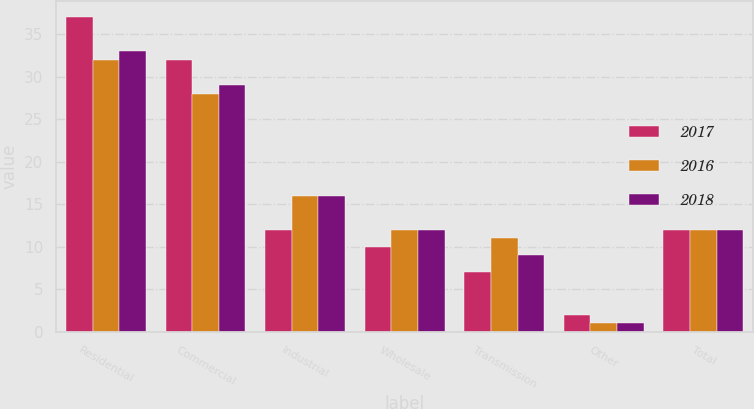Convert chart to OTSL. <chart><loc_0><loc_0><loc_500><loc_500><stacked_bar_chart><ecel><fcel>Residential<fcel>Commercial<fcel>Industrial<fcel>Wholesale<fcel>Transmission<fcel>Other<fcel>Total<nl><fcel>2017<fcel>37<fcel>32<fcel>12<fcel>10<fcel>7<fcel>2<fcel>12<nl><fcel>2016<fcel>32<fcel>28<fcel>16<fcel>12<fcel>11<fcel>1<fcel>12<nl><fcel>2018<fcel>33<fcel>29<fcel>16<fcel>12<fcel>9<fcel>1<fcel>12<nl></chart> 